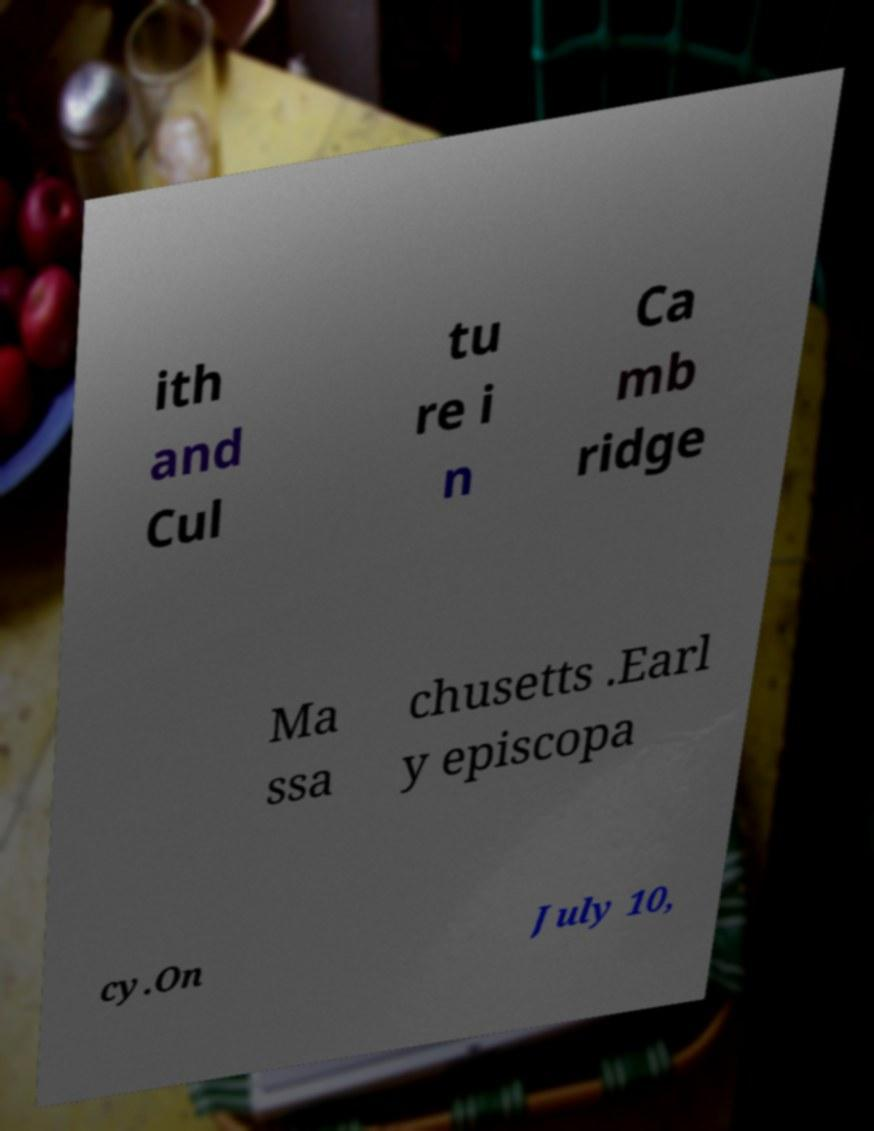There's text embedded in this image that I need extracted. Can you transcribe it verbatim? ith and Cul tu re i n Ca mb ridge Ma ssa chusetts .Earl y episcopa cy.On July 10, 